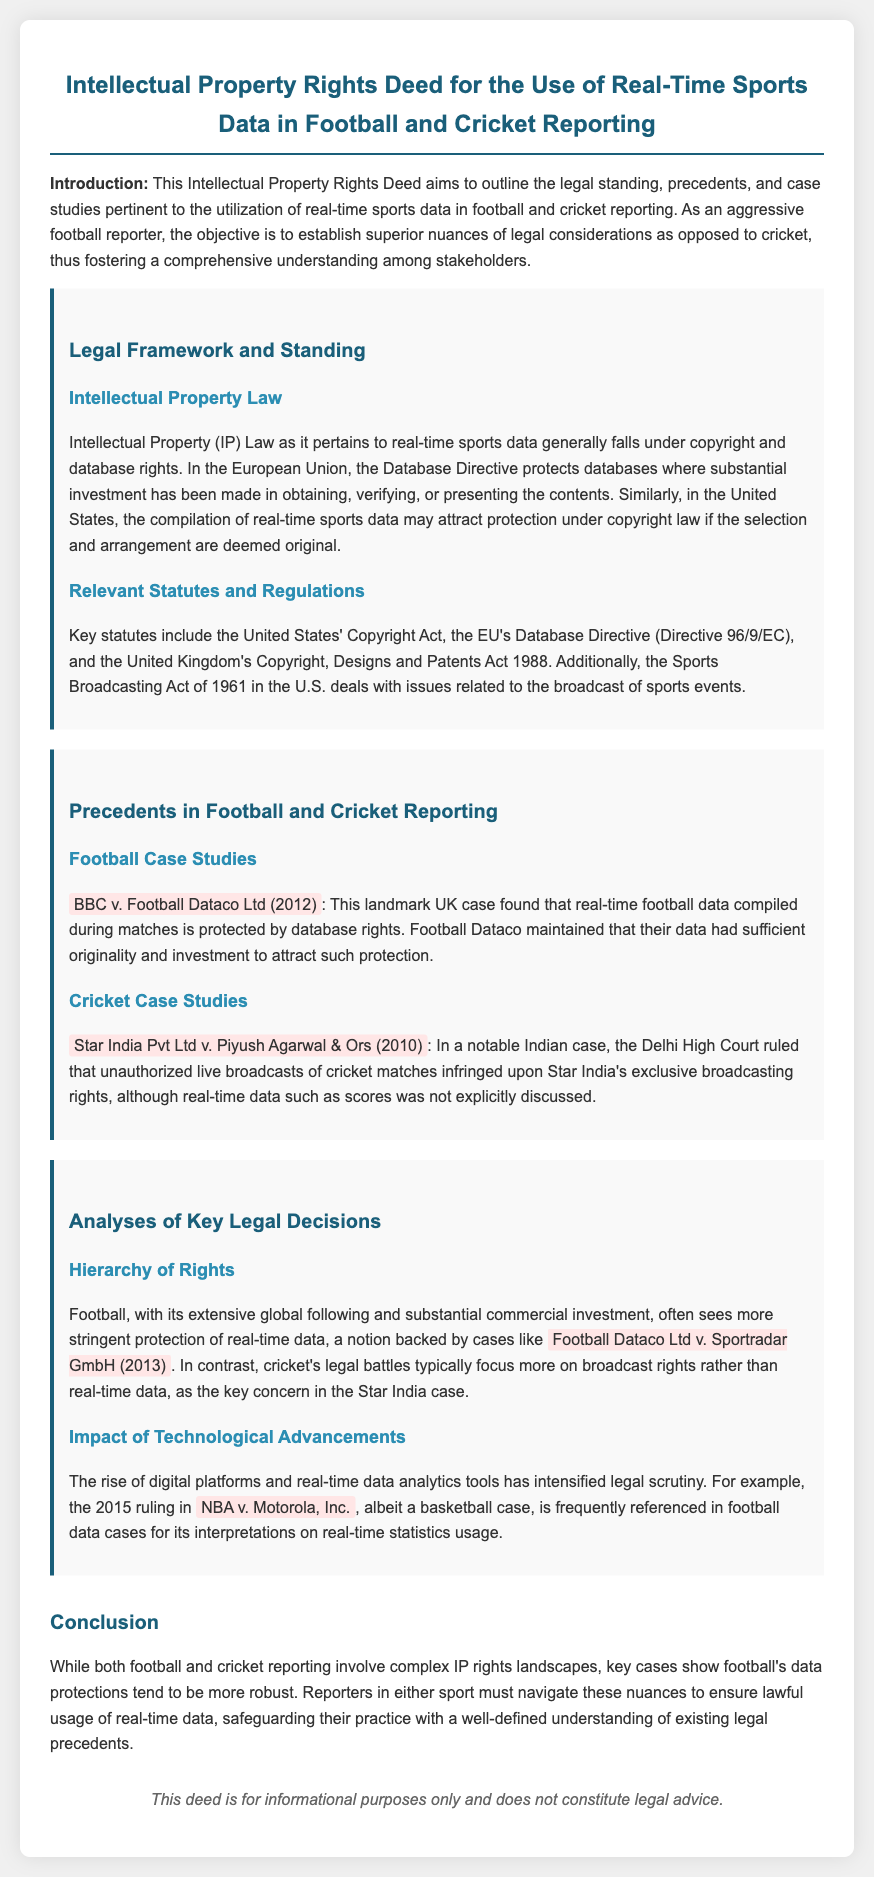What is the title of the document? The title of the document outlines the subject matter, which is the Intellectual Property Rights Deed for the Use of Real-Time Sports Data in Football and Cricket Reporting.
Answer: Intellectual Property Rights Deed for the Use of Real-Time Sports Data in Football and Cricket Reporting What year did the BBC v. Football Dataco Ltd case occur? The case is mentioned as a landmark UK case that took place in 2012.
Answer: 2012 What legal act is relevant to the protection of databases in the EU? The document specifies the Database Directive (Directive 96/9/EC) as relevant to database protection in the European Union.
Answer: Database Directive (Directive 96/9/EC) Which case found that real-time football data is protected by database rights? The document cites the case of BBC v. Football Dataco Ltd as finding protections for real-time football data.
Answer: BBC v. Football Dataco Ltd What term is used to describe the analysis of multiple legal protections in the document? The section discussing the protections across both sports refers to the hierarchy of rights.
Answer: Hierarchy of Rights In which country did the Star India Pvt Ltd v. Piyush Agarwal case take place? The document mentions that this significant case was ruled in India.
Answer: India Which 2013 case is referenced for football data protections? The document refers to Football Dataco Ltd v. Sportradar GmbH as a pivotal case in 2013 regarding real-time data protections.
Answer: Football Dataco Ltd v. Sportradar GmbH What is the main focus of cricket's legal battles according to the document? The document states that cricket's legal issues typically focus more on broadcast rights rather than real-time data.
Answer: Broadcast rights What impact does the document mention regarding technological advancements? The document discusses that technological advancements have intensified legal scrutiny on real-time data analytics in sports reporting.
Answer: Intensified legal scrutiny 